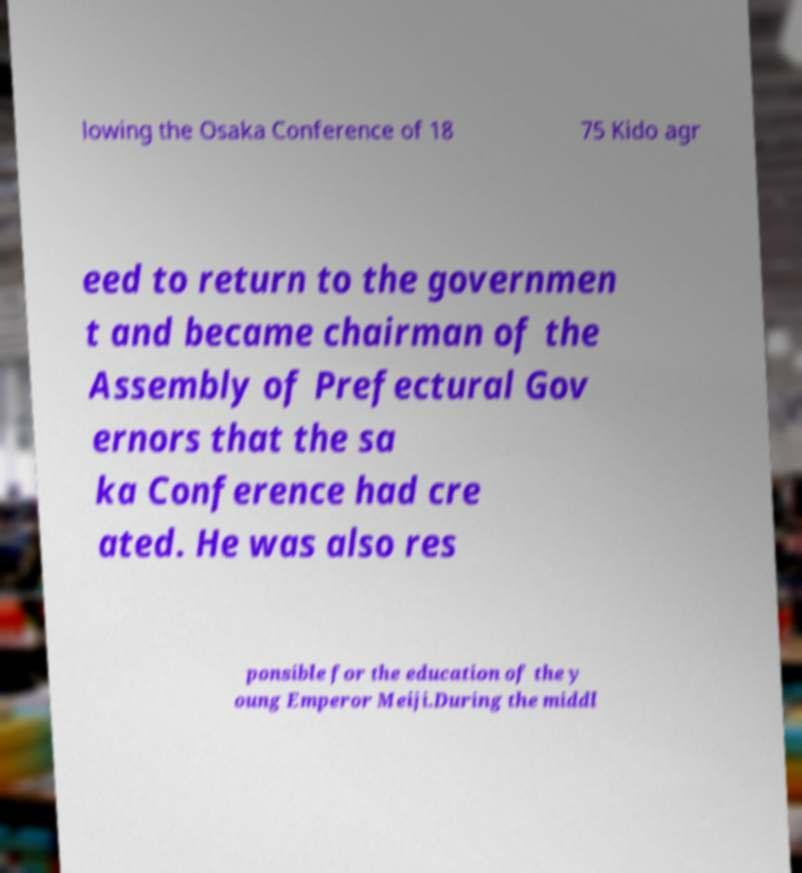Could you extract and type out the text from this image? lowing the Osaka Conference of 18 75 Kido agr eed to return to the governmen t and became chairman of the Assembly of Prefectural Gov ernors that the sa ka Conference had cre ated. He was also res ponsible for the education of the y oung Emperor Meiji.During the middl 